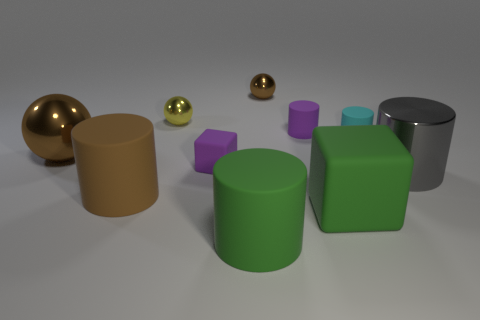What is the shape of the small metallic object that is the same color as the large ball?
Keep it short and to the point. Sphere. Are the tiny purple block and the cyan cylinder made of the same material?
Give a very brief answer. Yes. What number of other objects are the same size as the purple block?
Make the answer very short. 4. There is a rubber block behind the large brown object that is in front of the gray shiny cylinder; what size is it?
Keep it short and to the point. Small. There is a rubber block that is behind the big metal thing on the right side of the brown thing that is behind the yellow metallic thing; what color is it?
Give a very brief answer. Purple. There is a shiny ball that is to the left of the green cylinder and on the right side of the large brown rubber cylinder; what size is it?
Provide a succinct answer. Small. What number of other things are there of the same shape as the small cyan matte object?
Give a very brief answer. 4. What number of cylinders are either purple rubber objects or large green things?
Your answer should be compact. 2. There is a green thing that is in front of the cube in front of the large brown rubber cylinder; are there any large green matte cubes on the left side of it?
Keep it short and to the point. No. There is another tiny object that is the same shape as the tiny cyan matte thing; what is its color?
Your answer should be very brief. Purple. 